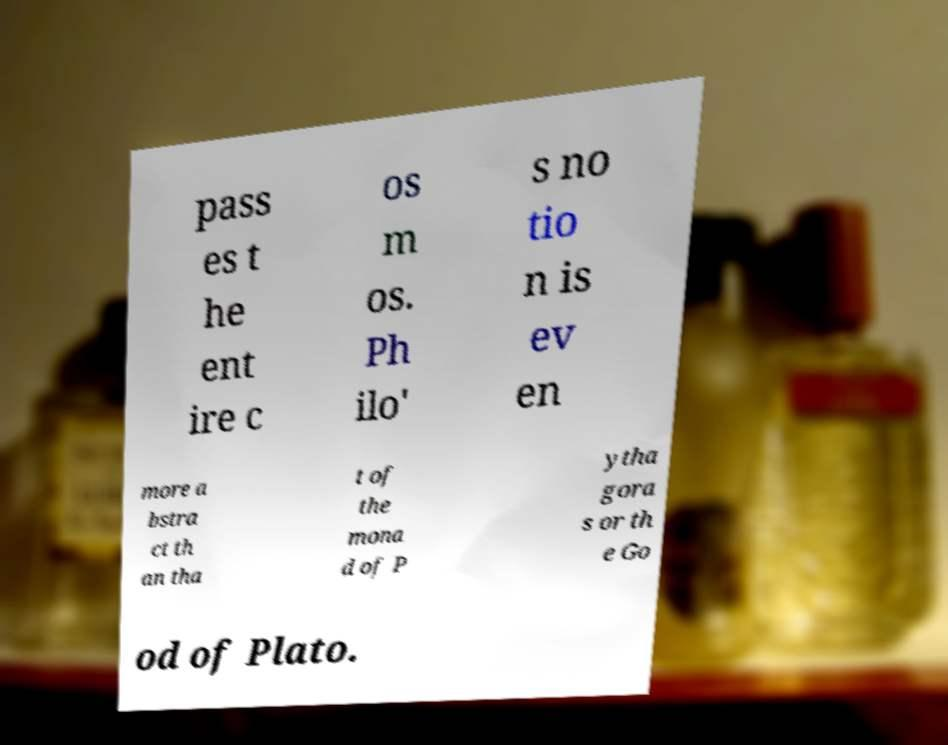Could you extract and type out the text from this image? pass es t he ent ire c os m os. Ph ilo' s no tio n is ev en more a bstra ct th an tha t of the mona d of P ytha gora s or th e Go od of Plato. 